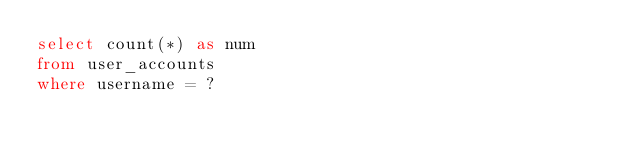Convert code to text. <code><loc_0><loc_0><loc_500><loc_500><_SQL_>select count(*) as num
from user_accounts
where username = ?
</code> 